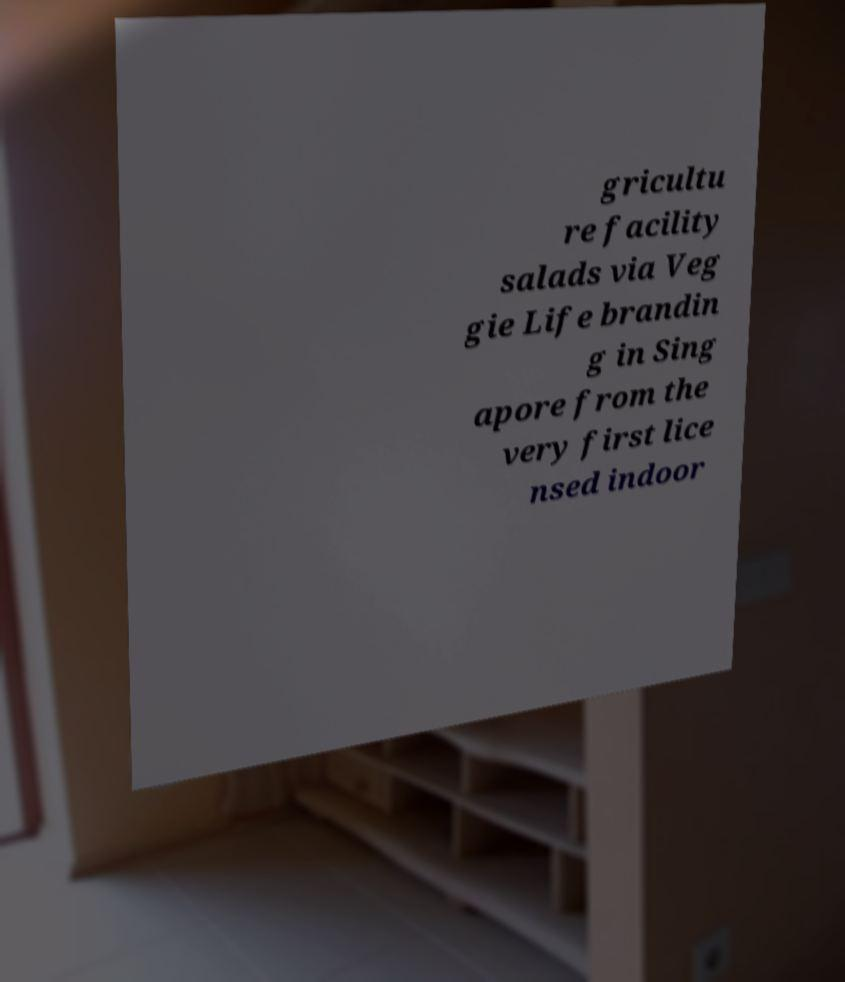Please identify and transcribe the text found in this image. gricultu re facility salads via Veg gie Life brandin g in Sing apore from the very first lice nsed indoor 